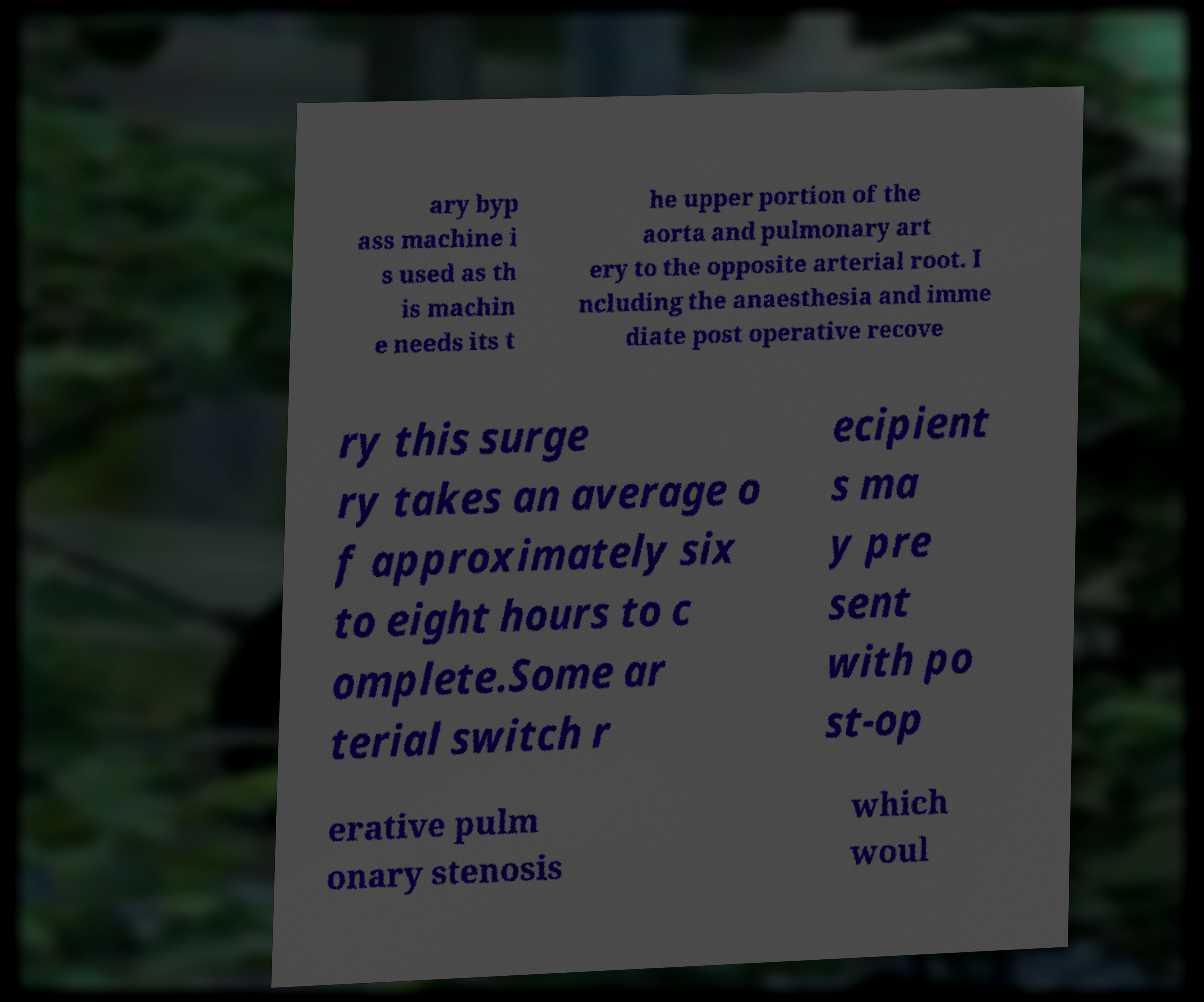Can you read and provide the text displayed in the image?This photo seems to have some interesting text. Can you extract and type it out for me? ary byp ass machine i s used as th is machin e needs its t he upper portion of the aorta and pulmonary art ery to the opposite arterial root. I ncluding the anaesthesia and imme diate post operative recove ry this surge ry takes an average o f approximately six to eight hours to c omplete.Some ar terial switch r ecipient s ma y pre sent with po st-op erative pulm onary stenosis which woul 